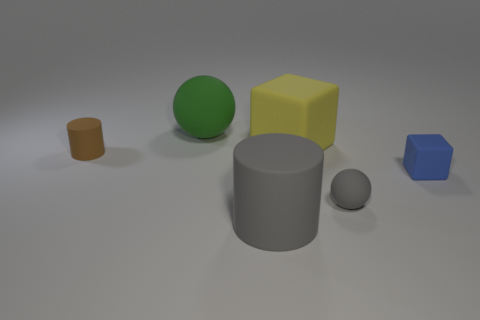Is there anything else that has the same shape as the large yellow matte thing?
Make the answer very short. Yes. What number of tiny green balls are there?
Offer a very short reply. 0. How many gray things are large cubes or large balls?
Keep it short and to the point. 0. What number of other things are made of the same material as the big yellow thing?
Offer a very short reply. 5. What material is the large cylinder?
Your answer should be very brief. Rubber. There is a block that is behind the tiny blue cube; how big is it?
Offer a very short reply. Large. What number of gray matte cylinders are in front of the large rubber cube left of the tiny rubber cube?
Offer a terse response. 1. Is the shape of the tiny thing that is left of the big gray rubber thing the same as the object that is behind the yellow block?
Keep it short and to the point. No. How many matte objects are both behind the small brown rubber cylinder and right of the yellow rubber cube?
Offer a very short reply. 0. Is there a rubber cube of the same color as the small rubber sphere?
Your response must be concise. No. 